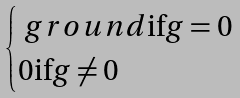<formula> <loc_0><loc_0><loc_500><loc_500>\begin{cases} { \ g r o u n d \text {if} g = 0 } \\ { 0 \text {if} g \neq 0 } \end{cases}</formula> 